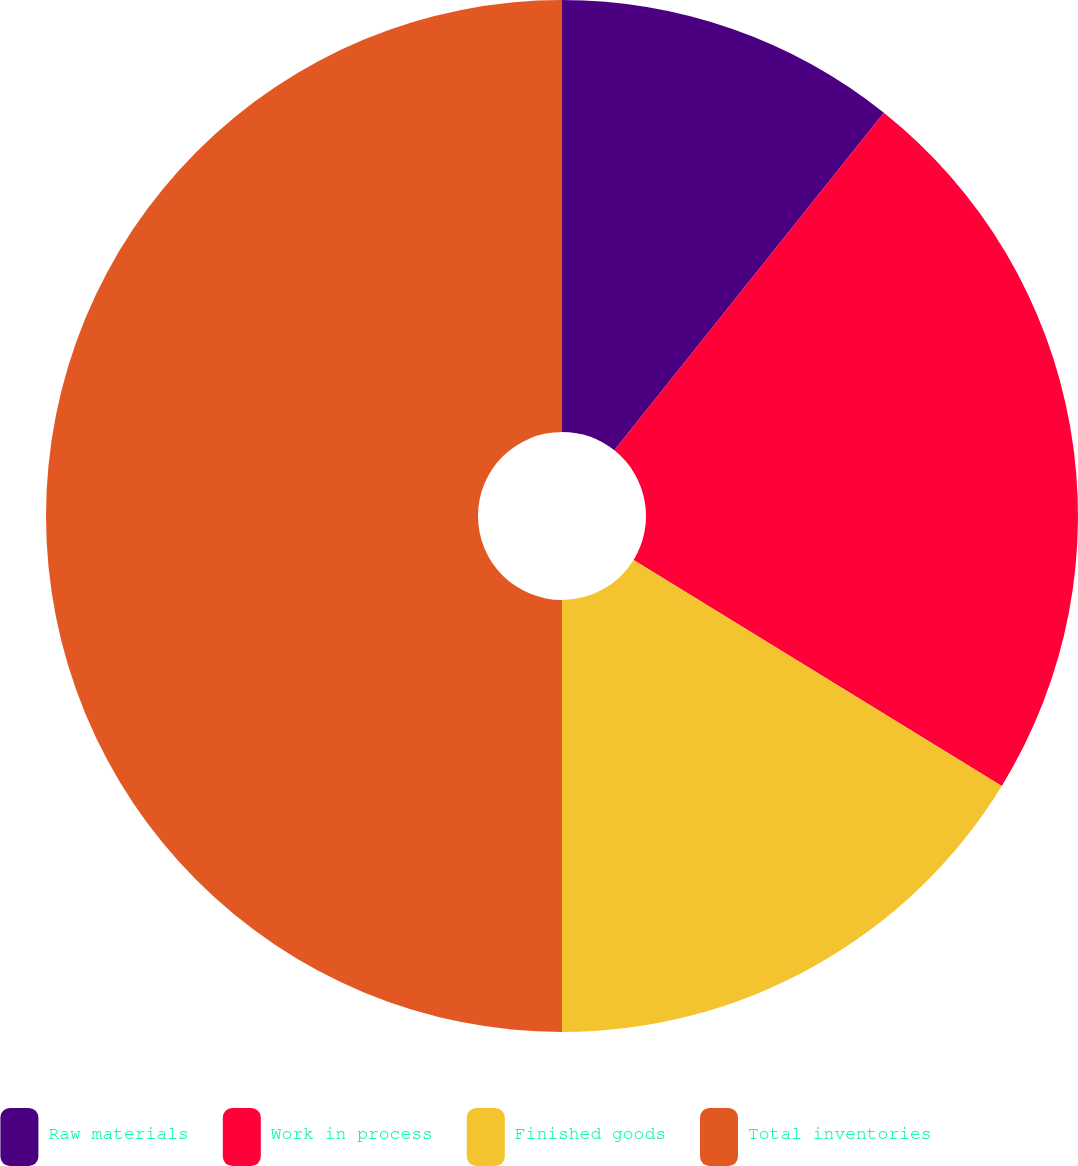Convert chart. <chart><loc_0><loc_0><loc_500><loc_500><pie_chart><fcel>Raw materials<fcel>Work in process<fcel>Finished goods<fcel>Total inventories<nl><fcel>10.72%<fcel>23.04%<fcel>16.24%<fcel>50.0%<nl></chart> 